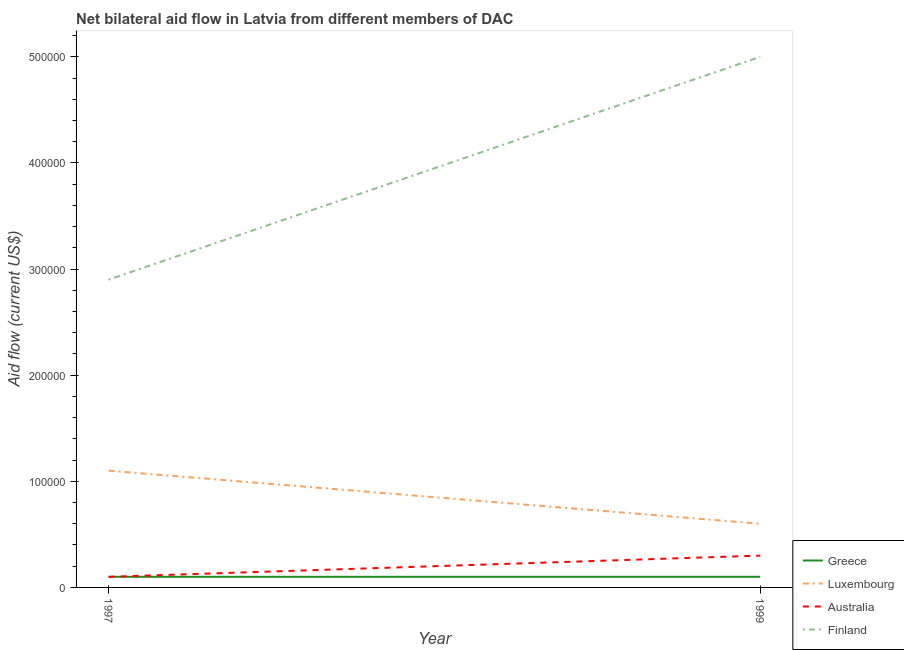How many different coloured lines are there?
Provide a short and direct response. 4. Does the line corresponding to amount of aid given by australia intersect with the line corresponding to amount of aid given by greece?
Offer a terse response. Yes. What is the amount of aid given by australia in 1999?
Provide a short and direct response. 3.00e+04. Across all years, what is the maximum amount of aid given by finland?
Provide a succinct answer. 5.00e+05. Across all years, what is the minimum amount of aid given by finland?
Provide a succinct answer. 2.90e+05. In which year was the amount of aid given by luxembourg maximum?
Keep it short and to the point. 1997. In which year was the amount of aid given by luxembourg minimum?
Your answer should be compact. 1999. What is the total amount of aid given by luxembourg in the graph?
Your response must be concise. 1.70e+05. What is the difference between the amount of aid given by australia in 1997 and the amount of aid given by finland in 1999?
Make the answer very short. -4.90e+05. What is the average amount of aid given by greece per year?
Make the answer very short. 10000. In the year 1999, what is the difference between the amount of aid given by greece and amount of aid given by australia?
Your answer should be compact. -2.00e+04. What is the ratio of the amount of aid given by australia in 1997 to that in 1999?
Offer a terse response. 0.33. In how many years, is the amount of aid given by greece greater than the average amount of aid given by greece taken over all years?
Give a very brief answer. 0. Is it the case that in every year, the sum of the amount of aid given by luxembourg and amount of aid given by greece is greater than the sum of amount of aid given by australia and amount of aid given by finland?
Your answer should be very brief. No. How many lines are there?
Provide a succinct answer. 4. How many years are there in the graph?
Provide a succinct answer. 2. Does the graph contain any zero values?
Your answer should be compact. No. What is the title of the graph?
Ensure brevity in your answer.  Net bilateral aid flow in Latvia from different members of DAC. What is the Aid flow (current US$) of Greece in 1997?
Give a very brief answer. 10000. What is the Aid flow (current US$) of Luxembourg in 1997?
Offer a terse response. 1.10e+05. What is the Aid flow (current US$) in Australia in 1997?
Keep it short and to the point. 10000. What is the Aid flow (current US$) of Greece in 1999?
Your response must be concise. 10000. Across all years, what is the maximum Aid flow (current US$) in Luxembourg?
Keep it short and to the point. 1.10e+05. Across all years, what is the minimum Aid flow (current US$) in Australia?
Make the answer very short. 10000. Across all years, what is the minimum Aid flow (current US$) in Finland?
Provide a succinct answer. 2.90e+05. What is the total Aid flow (current US$) in Finland in the graph?
Your answer should be compact. 7.90e+05. What is the difference between the Aid flow (current US$) in Greece in 1997 and that in 1999?
Your response must be concise. 0. What is the difference between the Aid flow (current US$) in Luxembourg in 1997 and that in 1999?
Make the answer very short. 5.00e+04. What is the difference between the Aid flow (current US$) of Australia in 1997 and that in 1999?
Make the answer very short. -2.00e+04. What is the difference between the Aid flow (current US$) in Finland in 1997 and that in 1999?
Provide a succinct answer. -2.10e+05. What is the difference between the Aid flow (current US$) of Greece in 1997 and the Aid flow (current US$) of Luxembourg in 1999?
Keep it short and to the point. -5.00e+04. What is the difference between the Aid flow (current US$) of Greece in 1997 and the Aid flow (current US$) of Australia in 1999?
Give a very brief answer. -2.00e+04. What is the difference between the Aid flow (current US$) of Greece in 1997 and the Aid flow (current US$) of Finland in 1999?
Keep it short and to the point. -4.90e+05. What is the difference between the Aid flow (current US$) in Luxembourg in 1997 and the Aid flow (current US$) in Australia in 1999?
Give a very brief answer. 8.00e+04. What is the difference between the Aid flow (current US$) in Luxembourg in 1997 and the Aid flow (current US$) in Finland in 1999?
Keep it short and to the point. -3.90e+05. What is the difference between the Aid flow (current US$) in Australia in 1997 and the Aid flow (current US$) in Finland in 1999?
Provide a succinct answer. -4.90e+05. What is the average Aid flow (current US$) in Greece per year?
Offer a very short reply. 10000. What is the average Aid flow (current US$) in Luxembourg per year?
Provide a succinct answer. 8.50e+04. What is the average Aid flow (current US$) in Finland per year?
Provide a short and direct response. 3.95e+05. In the year 1997, what is the difference between the Aid flow (current US$) of Greece and Aid flow (current US$) of Luxembourg?
Ensure brevity in your answer.  -1.00e+05. In the year 1997, what is the difference between the Aid flow (current US$) of Greece and Aid flow (current US$) of Finland?
Give a very brief answer. -2.80e+05. In the year 1997, what is the difference between the Aid flow (current US$) in Luxembourg and Aid flow (current US$) in Finland?
Ensure brevity in your answer.  -1.80e+05. In the year 1997, what is the difference between the Aid flow (current US$) in Australia and Aid flow (current US$) in Finland?
Your response must be concise. -2.80e+05. In the year 1999, what is the difference between the Aid flow (current US$) in Greece and Aid flow (current US$) in Luxembourg?
Offer a very short reply. -5.00e+04. In the year 1999, what is the difference between the Aid flow (current US$) of Greece and Aid flow (current US$) of Australia?
Ensure brevity in your answer.  -2.00e+04. In the year 1999, what is the difference between the Aid flow (current US$) of Greece and Aid flow (current US$) of Finland?
Provide a succinct answer. -4.90e+05. In the year 1999, what is the difference between the Aid flow (current US$) of Luxembourg and Aid flow (current US$) of Australia?
Offer a very short reply. 3.00e+04. In the year 1999, what is the difference between the Aid flow (current US$) of Luxembourg and Aid flow (current US$) of Finland?
Your response must be concise. -4.40e+05. In the year 1999, what is the difference between the Aid flow (current US$) in Australia and Aid flow (current US$) in Finland?
Ensure brevity in your answer.  -4.70e+05. What is the ratio of the Aid flow (current US$) of Greece in 1997 to that in 1999?
Offer a very short reply. 1. What is the ratio of the Aid flow (current US$) of Luxembourg in 1997 to that in 1999?
Your answer should be compact. 1.83. What is the ratio of the Aid flow (current US$) in Finland in 1997 to that in 1999?
Offer a terse response. 0.58. What is the difference between the highest and the second highest Aid flow (current US$) of Greece?
Offer a very short reply. 0. What is the difference between the highest and the lowest Aid flow (current US$) of Greece?
Give a very brief answer. 0. 